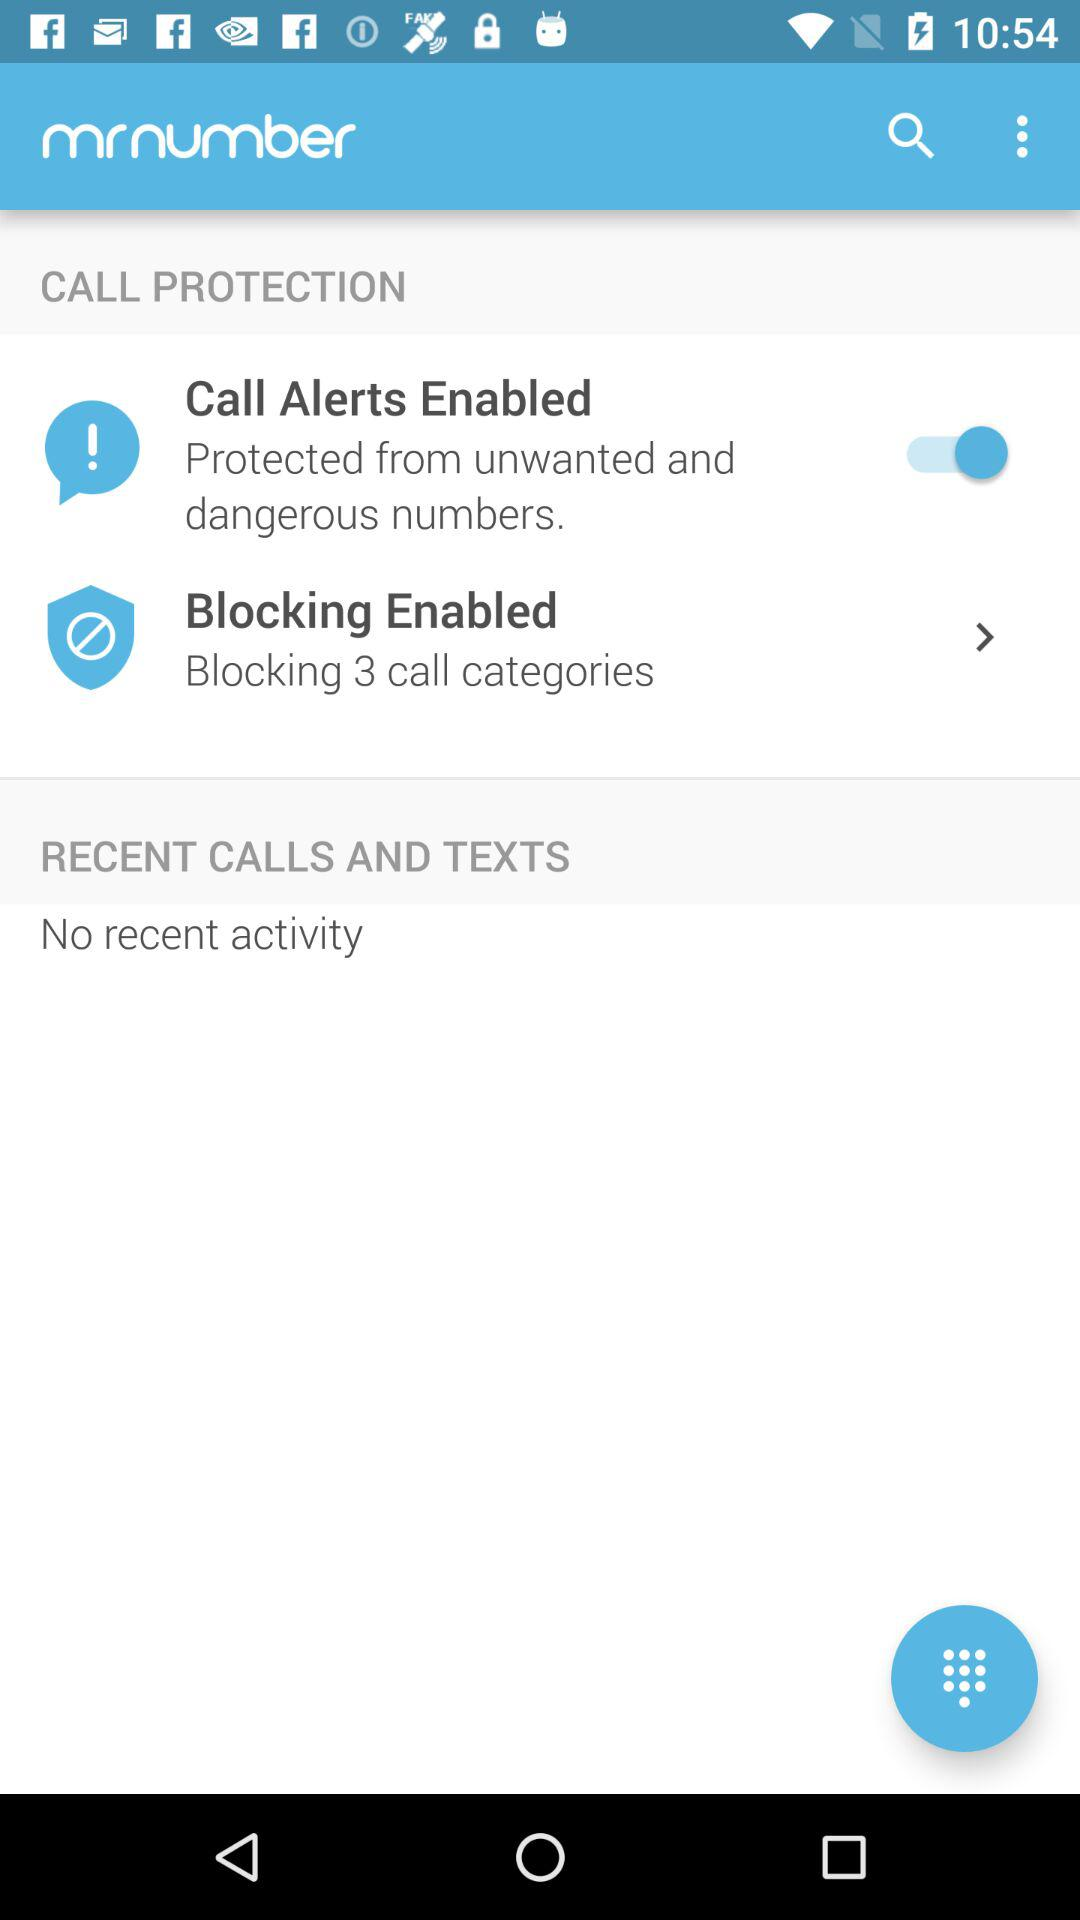Is there any recent calls and texts activity? There is no recent activity. 